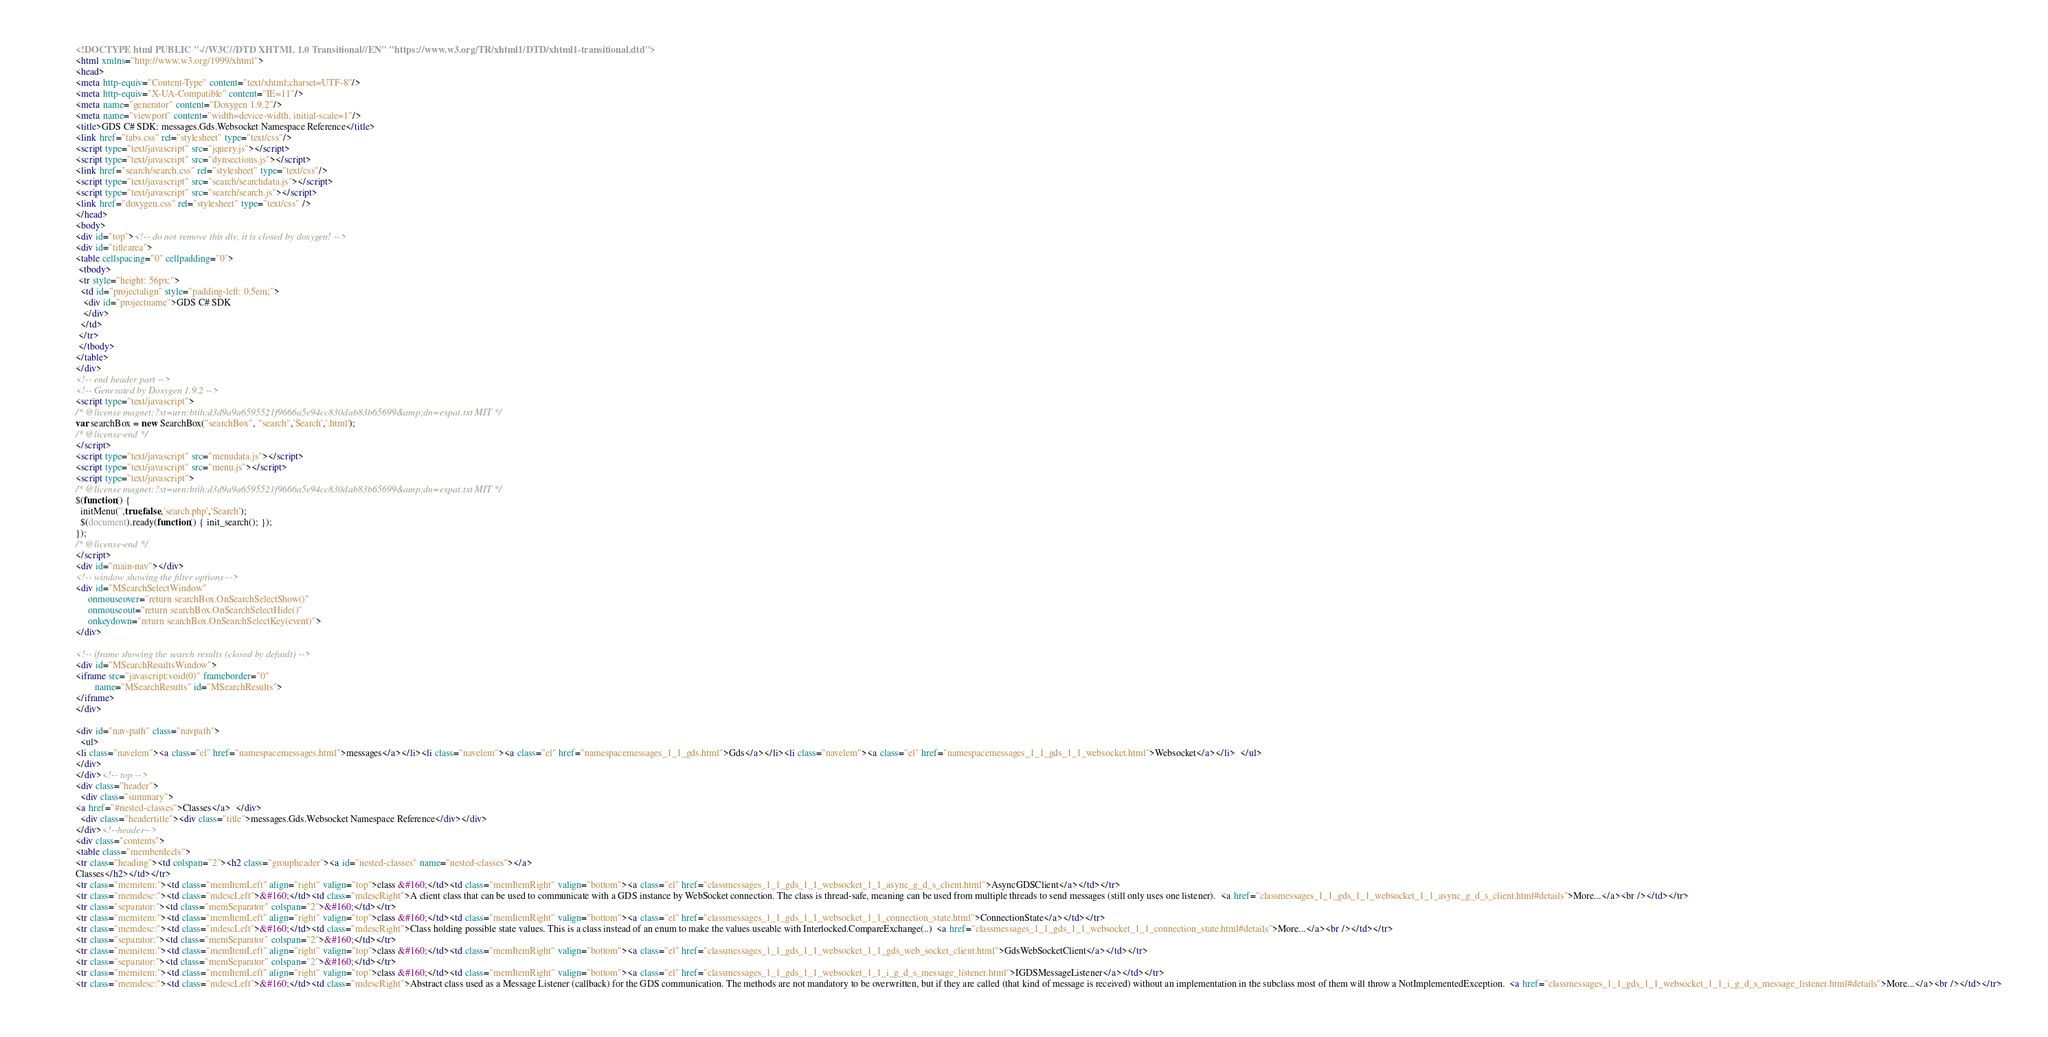Convert code to text. <code><loc_0><loc_0><loc_500><loc_500><_HTML_><!DOCTYPE html PUBLIC "-//W3C//DTD XHTML 1.0 Transitional//EN" "https://www.w3.org/TR/xhtml1/DTD/xhtml1-transitional.dtd">
<html xmlns="http://www.w3.org/1999/xhtml">
<head>
<meta http-equiv="Content-Type" content="text/xhtml;charset=UTF-8"/>
<meta http-equiv="X-UA-Compatible" content="IE=11"/>
<meta name="generator" content="Doxygen 1.9.2"/>
<meta name="viewport" content="width=device-width, initial-scale=1"/>
<title>GDS C# SDK: messages.Gds.Websocket Namespace Reference</title>
<link href="tabs.css" rel="stylesheet" type="text/css"/>
<script type="text/javascript" src="jquery.js"></script>
<script type="text/javascript" src="dynsections.js"></script>
<link href="search/search.css" rel="stylesheet" type="text/css"/>
<script type="text/javascript" src="search/searchdata.js"></script>
<script type="text/javascript" src="search/search.js"></script>
<link href="doxygen.css" rel="stylesheet" type="text/css" />
</head>
<body>
<div id="top"><!-- do not remove this div, it is closed by doxygen! -->
<div id="titlearea">
<table cellspacing="0" cellpadding="0">
 <tbody>
 <tr style="height: 56px;">
  <td id="projectalign" style="padding-left: 0.5em;">
   <div id="projectname">GDS C# SDK
   </div>
  </td>
 </tr>
 </tbody>
</table>
</div>
<!-- end header part -->
<!-- Generated by Doxygen 1.9.2 -->
<script type="text/javascript">
/* @license magnet:?xt=urn:btih:d3d9a9a6595521f9666a5e94cc830dab83b65699&amp;dn=expat.txt MIT */
var searchBox = new SearchBox("searchBox", "search",'Search','.html');
/* @license-end */
</script>
<script type="text/javascript" src="menudata.js"></script>
<script type="text/javascript" src="menu.js"></script>
<script type="text/javascript">
/* @license magnet:?xt=urn:btih:d3d9a9a6595521f9666a5e94cc830dab83b65699&amp;dn=expat.txt MIT */
$(function() {
  initMenu('',true,false,'search.php','Search');
  $(document).ready(function() { init_search(); });
});
/* @license-end */
</script>
<div id="main-nav"></div>
<!-- window showing the filter options -->
<div id="MSearchSelectWindow"
     onmouseover="return searchBox.OnSearchSelectShow()"
     onmouseout="return searchBox.OnSearchSelectHide()"
     onkeydown="return searchBox.OnSearchSelectKey(event)">
</div>

<!-- iframe showing the search results (closed by default) -->
<div id="MSearchResultsWindow">
<iframe src="javascript:void(0)" frameborder="0" 
        name="MSearchResults" id="MSearchResults">
</iframe>
</div>

<div id="nav-path" class="navpath">
  <ul>
<li class="navelem"><a class="el" href="namespacemessages.html">messages</a></li><li class="navelem"><a class="el" href="namespacemessages_1_1_gds.html">Gds</a></li><li class="navelem"><a class="el" href="namespacemessages_1_1_gds_1_1_websocket.html">Websocket</a></li>  </ul>
</div>
</div><!-- top -->
<div class="header">
  <div class="summary">
<a href="#nested-classes">Classes</a>  </div>
  <div class="headertitle"><div class="title">messages.Gds.Websocket Namespace Reference</div></div>
</div><!--header-->
<div class="contents">
<table class="memberdecls">
<tr class="heading"><td colspan="2"><h2 class="groupheader"><a id="nested-classes" name="nested-classes"></a>
Classes</h2></td></tr>
<tr class="memitem:"><td class="memItemLeft" align="right" valign="top">class &#160;</td><td class="memItemRight" valign="bottom"><a class="el" href="classmessages_1_1_gds_1_1_websocket_1_1_async_g_d_s_client.html">AsyncGDSClient</a></td></tr>
<tr class="memdesc:"><td class="mdescLeft">&#160;</td><td class="mdescRight">A client class that can be used to communicate with a GDS instance by WebSocket connection. The class is thread-safe, meaning can be used from multiple threads to send messages (still only uses one listener).  <a href="classmessages_1_1_gds_1_1_websocket_1_1_async_g_d_s_client.html#details">More...</a><br /></td></tr>
<tr class="separator:"><td class="memSeparator" colspan="2">&#160;</td></tr>
<tr class="memitem:"><td class="memItemLeft" align="right" valign="top">class &#160;</td><td class="memItemRight" valign="bottom"><a class="el" href="classmessages_1_1_gds_1_1_websocket_1_1_connection_state.html">ConnectionState</a></td></tr>
<tr class="memdesc:"><td class="mdescLeft">&#160;</td><td class="mdescRight">Class holding possible state values. This is a class instead of an enum to make the values useable with Interlocked.CompareExchange(..)  <a href="classmessages_1_1_gds_1_1_websocket_1_1_connection_state.html#details">More...</a><br /></td></tr>
<tr class="separator:"><td class="memSeparator" colspan="2">&#160;</td></tr>
<tr class="memitem:"><td class="memItemLeft" align="right" valign="top">class &#160;</td><td class="memItemRight" valign="bottom"><a class="el" href="classmessages_1_1_gds_1_1_websocket_1_1_gds_web_socket_client.html">GdsWebSocketClient</a></td></tr>
<tr class="separator:"><td class="memSeparator" colspan="2">&#160;</td></tr>
<tr class="memitem:"><td class="memItemLeft" align="right" valign="top">class &#160;</td><td class="memItemRight" valign="bottom"><a class="el" href="classmessages_1_1_gds_1_1_websocket_1_1_i_g_d_s_message_listener.html">IGDSMessageListener</a></td></tr>
<tr class="memdesc:"><td class="mdescLeft">&#160;</td><td class="mdescRight">Abstract class used as a Message Listener (callback) for the GDS communication. The methods are not mandatory to be overwritten, but if they are called (that kind of message is received) without an implementation in the subclass most of them will throw a NotImplementedException.  <a href="classmessages_1_1_gds_1_1_websocket_1_1_i_g_d_s_message_listener.html#details">More...</a><br /></td></tr></code> 